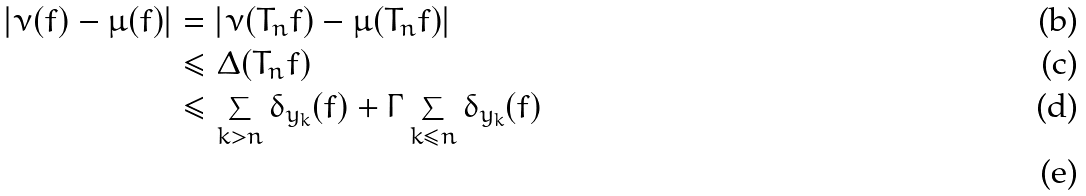Convert formula to latex. <formula><loc_0><loc_0><loc_500><loc_500>\left | \nu ( f ) - \mu ( f ) \right | & = \left | \nu ( T _ { n } f ) - \mu ( T _ { n } f ) \right | \\ & \leq \Delta ( T _ { n } f ) \\ & \leq \sum _ { k > n } \delta _ { y _ { k } } ( f ) + \Gamma \sum _ { k \leq n } \delta _ { y _ { k } } ( f ) \\</formula> 